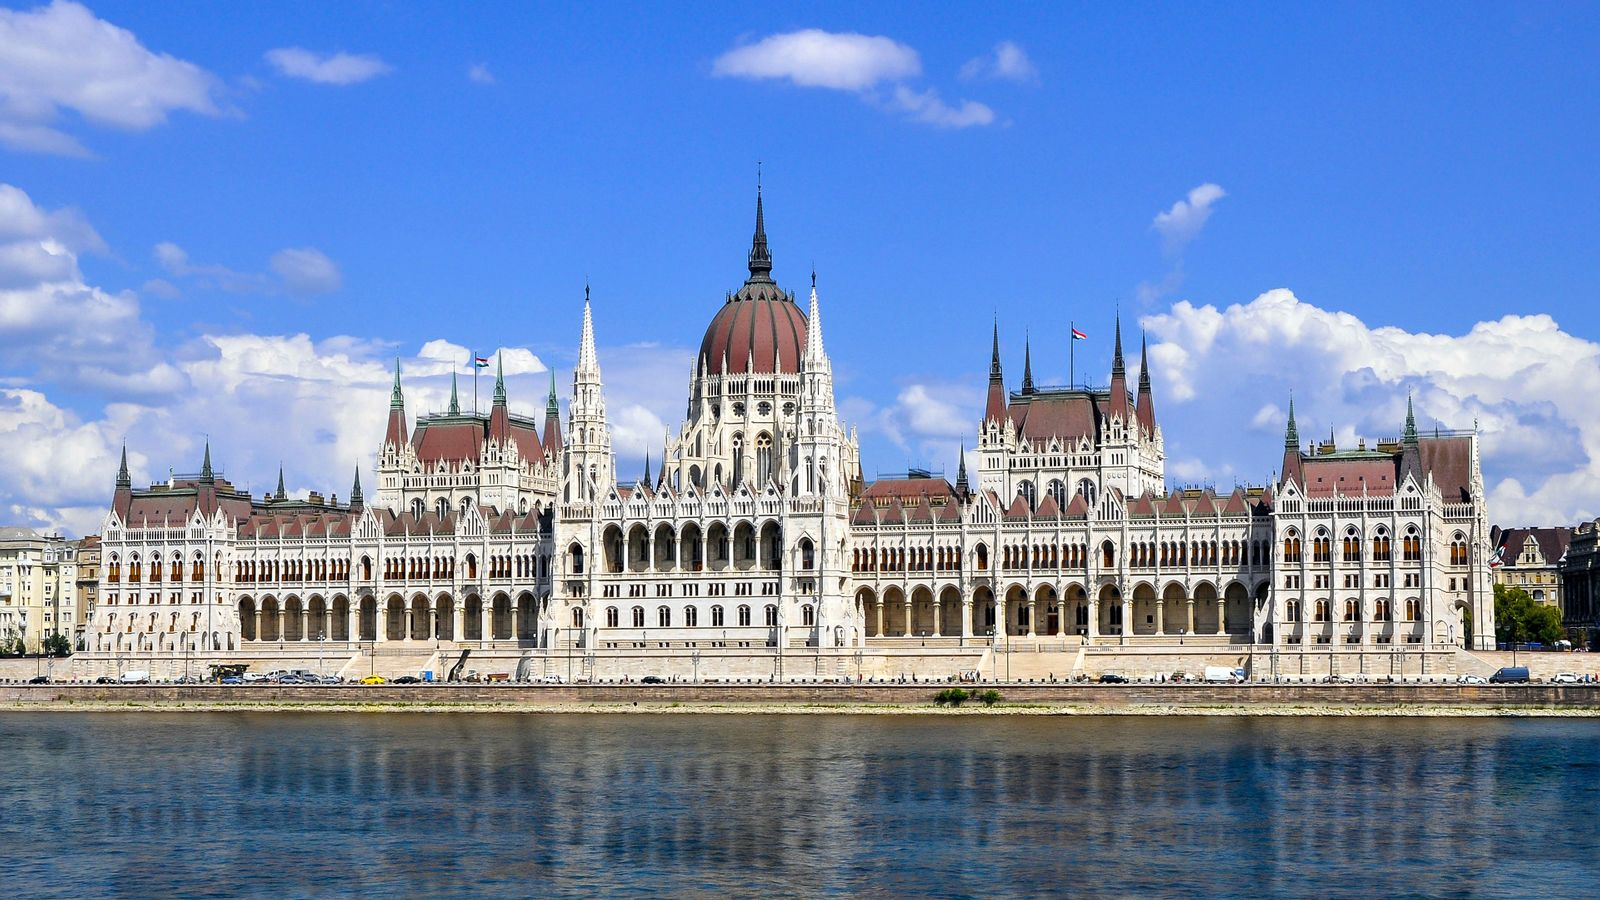A realistic scenario (short). Imagine walking along the banks of the Danube River on a sunny afternoon, with the Hungarian Parliament Building towering majestically on your left. The sunlight glints off the ornate spires, and tourists gather to take photos while locals go about their day. The ambiance is serene, with the gentle sound of water lapping against the riverbank. You feel a sense of history and admiration, enveloped by the beauty of Budapest’s most iconic landmark. 